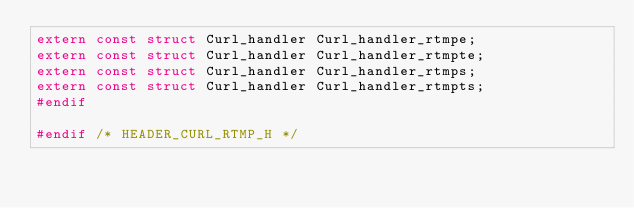<code> <loc_0><loc_0><loc_500><loc_500><_C_>extern const struct Curl_handler Curl_handler_rtmpe;
extern const struct Curl_handler Curl_handler_rtmpte;
extern const struct Curl_handler Curl_handler_rtmps;
extern const struct Curl_handler Curl_handler_rtmpts;
#endif

#endif /* HEADER_CURL_RTMP_H */
</code> 